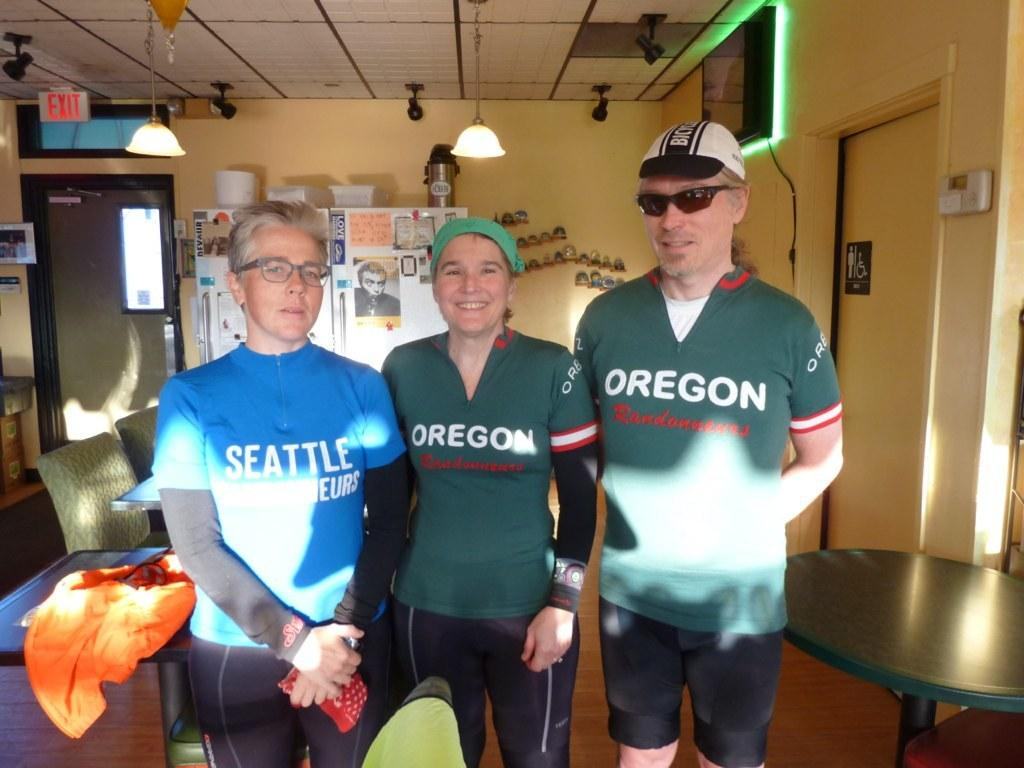<image>
Relay a brief, clear account of the picture shown. Two people in green Oregon shirts and one person in a blue Seattle shirt. 